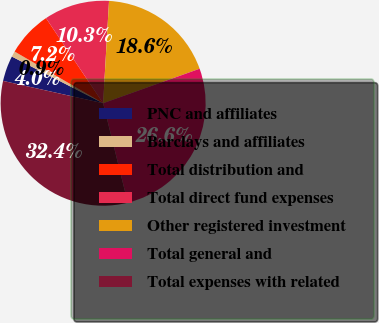<chart> <loc_0><loc_0><loc_500><loc_500><pie_chart><fcel>PNC and affiliates<fcel>Barclays and affiliates<fcel>Total distribution and<fcel>Total direct fund expenses<fcel>Other registered investment<fcel>Total general and<fcel>Total expenses with related<nl><fcel>4.03%<fcel>0.89%<fcel>7.18%<fcel>10.33%<fcel>18.62%<fcel>26.6%<fcel>32.36%<nl></chart> 